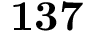Convert formula to latex. <formula><loc_0><loc_0><loc_500><loc_500>1 3 7</formula> 